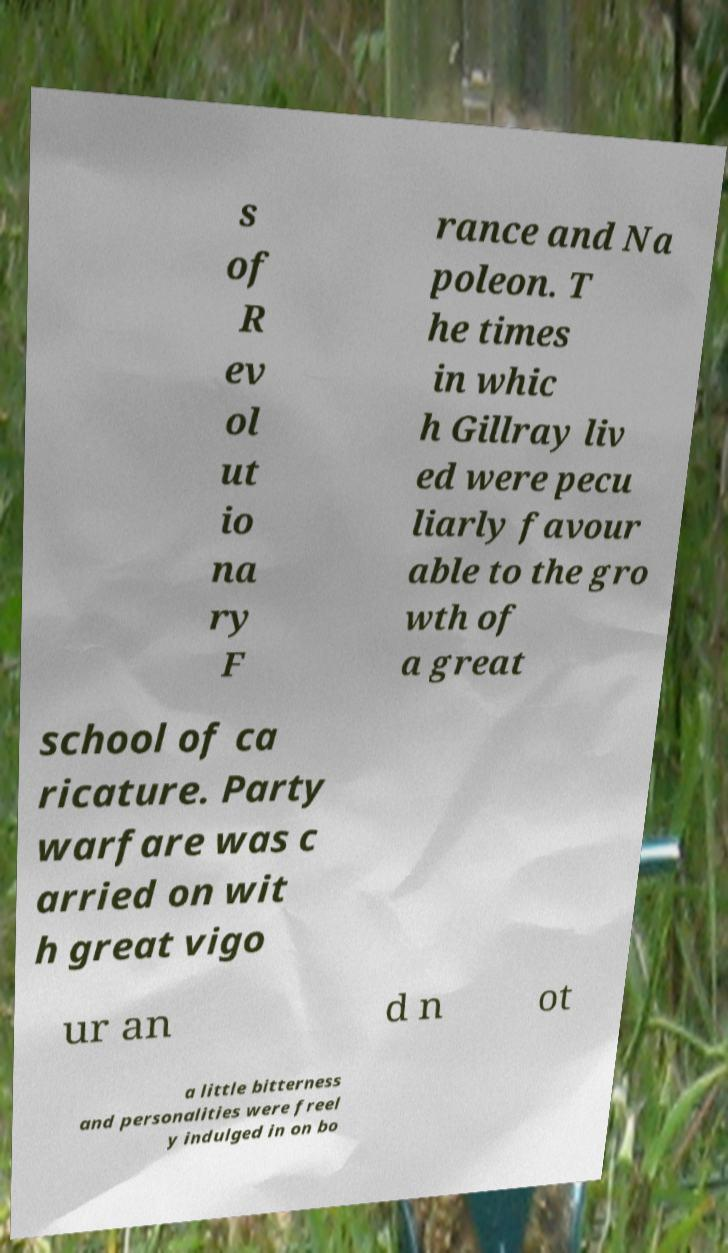Could you assist in decoding the text presented in this image and type it out clearly? s of R ev ol ut io na ry F rance and Na poleon. T he times in whic h Gillray liv ed were pecu liarly favour able to the gro wth of a great school of ca ricature. Party warfare was c arried on wit h great vigo ur an d n ot a little bitterness and personalities were freel y indulged in on bo 